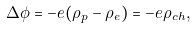<formula> <loc_0><loc_0><loc_500><loc_500>\Delta \phi = - e ( \rho _ { p } - \rho _ { e } ) = - e \rho _ { c h } ,</formula> 